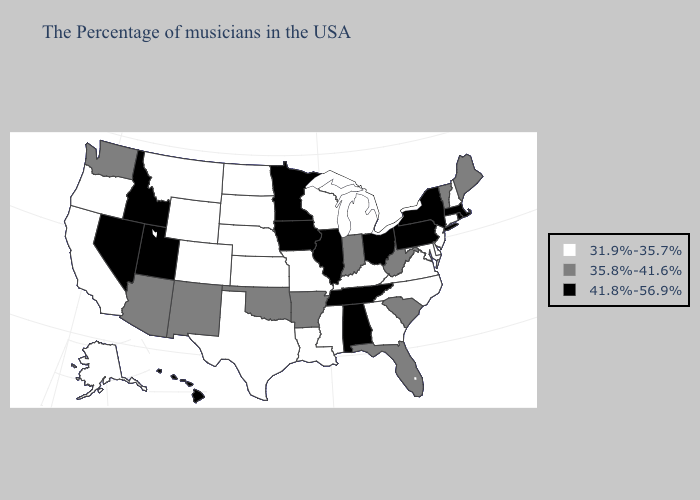What is the value of Vermont?
Short answer required. 35.8%-41.6%. Does North Dakota have the highest value in the USA?
Quick response, please. No. Among the states that border California , does Arizona have the highest value?
Quick response, please. No. Does Minnesota have a lower value than Connecticut?
Concise answer only. No. Name the states that have a value in the range 35.8%-41.6%?
Quick response, please. Maine, Vermont, South Carolina, West Virginia, Florida, Indiana, Arkansas, Oklahoma, New Mexico, Arizona, Washington. Which states have the highest value in the USA?
Answer briefly. Massachusetts, Rhode Island, New York, Pennsylvania, Ohio, Alabama, Tennessee, Illinois, Minnesota, Iowa, Utah, Idaho, Nevada, Hawaii. What is the value of North Carolina?
Give a very brief answer. 31.9%-35.7%. Does New York have the highest value in the Northeast?
Write a very short answer. Yes. What is the lowest value in the Northeast?
Quick response, please. 31.9%-35.7%. Does the first symbol in the legend represent the smallest category?
Answer briefly. Yes. What is the value of Wisconsin?
Be succinct. 31.9%-35.7%. What is the lowest value in the USA?
Keep it brief. 31.9%-35.7%. Name the states that have a value in the range 41.8%-56.9%?
Quick response, please. Massachusetts, Rhode Island, New York, Pennsylvania, Ohio, Alabama, Tennessee, Illinois, Minnesota, Iowa, Utah, Idaho, Nevada, Hawaii. 